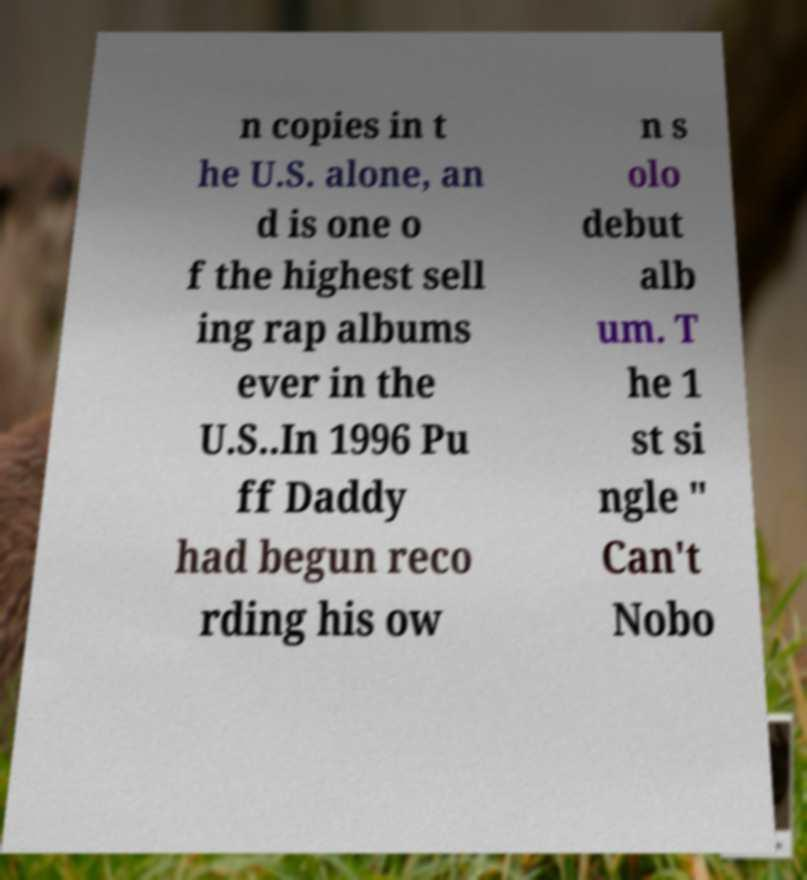Please read and relay the text visible in this image. What does it say? n copies in t he U.S. alone, an d is one o f the highest sell ing rap albums ever in the U.S..In 1996 Pu ff Daddy had begun reco rding his ow n s olo debut alb um. T he 1 st si ngle " Can't Nobo 